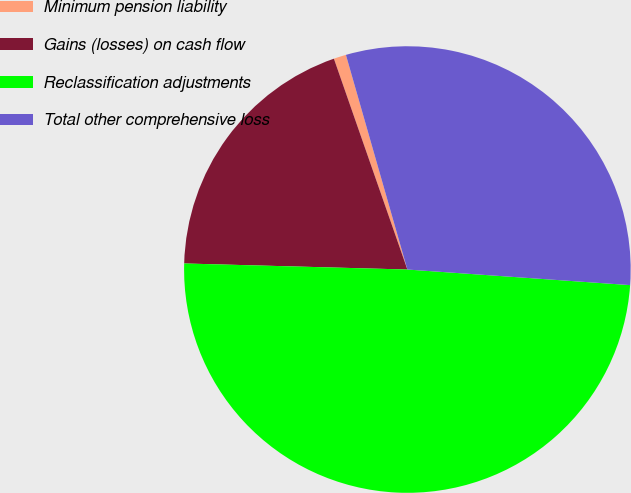<chart> <loc_0><loc_0><loc_500><loc_500><pie_chart><fcel>Minimum pension liability<fcel>Gains (losses) on cash flow<fcel>Reclassification adjustments<fcel>Total other comprehensive loss<nl><fcel>0.9%<fcel>19.23%<fcel>49.32%<fcel>30.55%<nl></chart> 